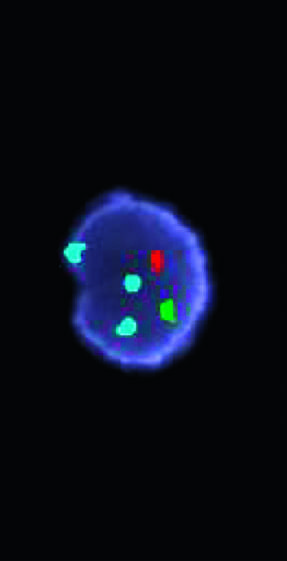how many copies does the aqua probe hybridize to the chromosome 18 centromere?
Answer the question using a single word or phrase. Three 